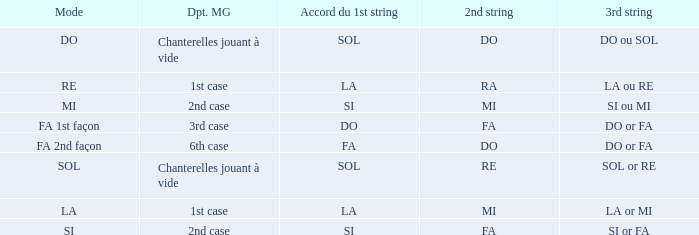For the 2nd string of Do and an Accord du 1st string of FA what is the Depart de la main gauche? 6th case. 